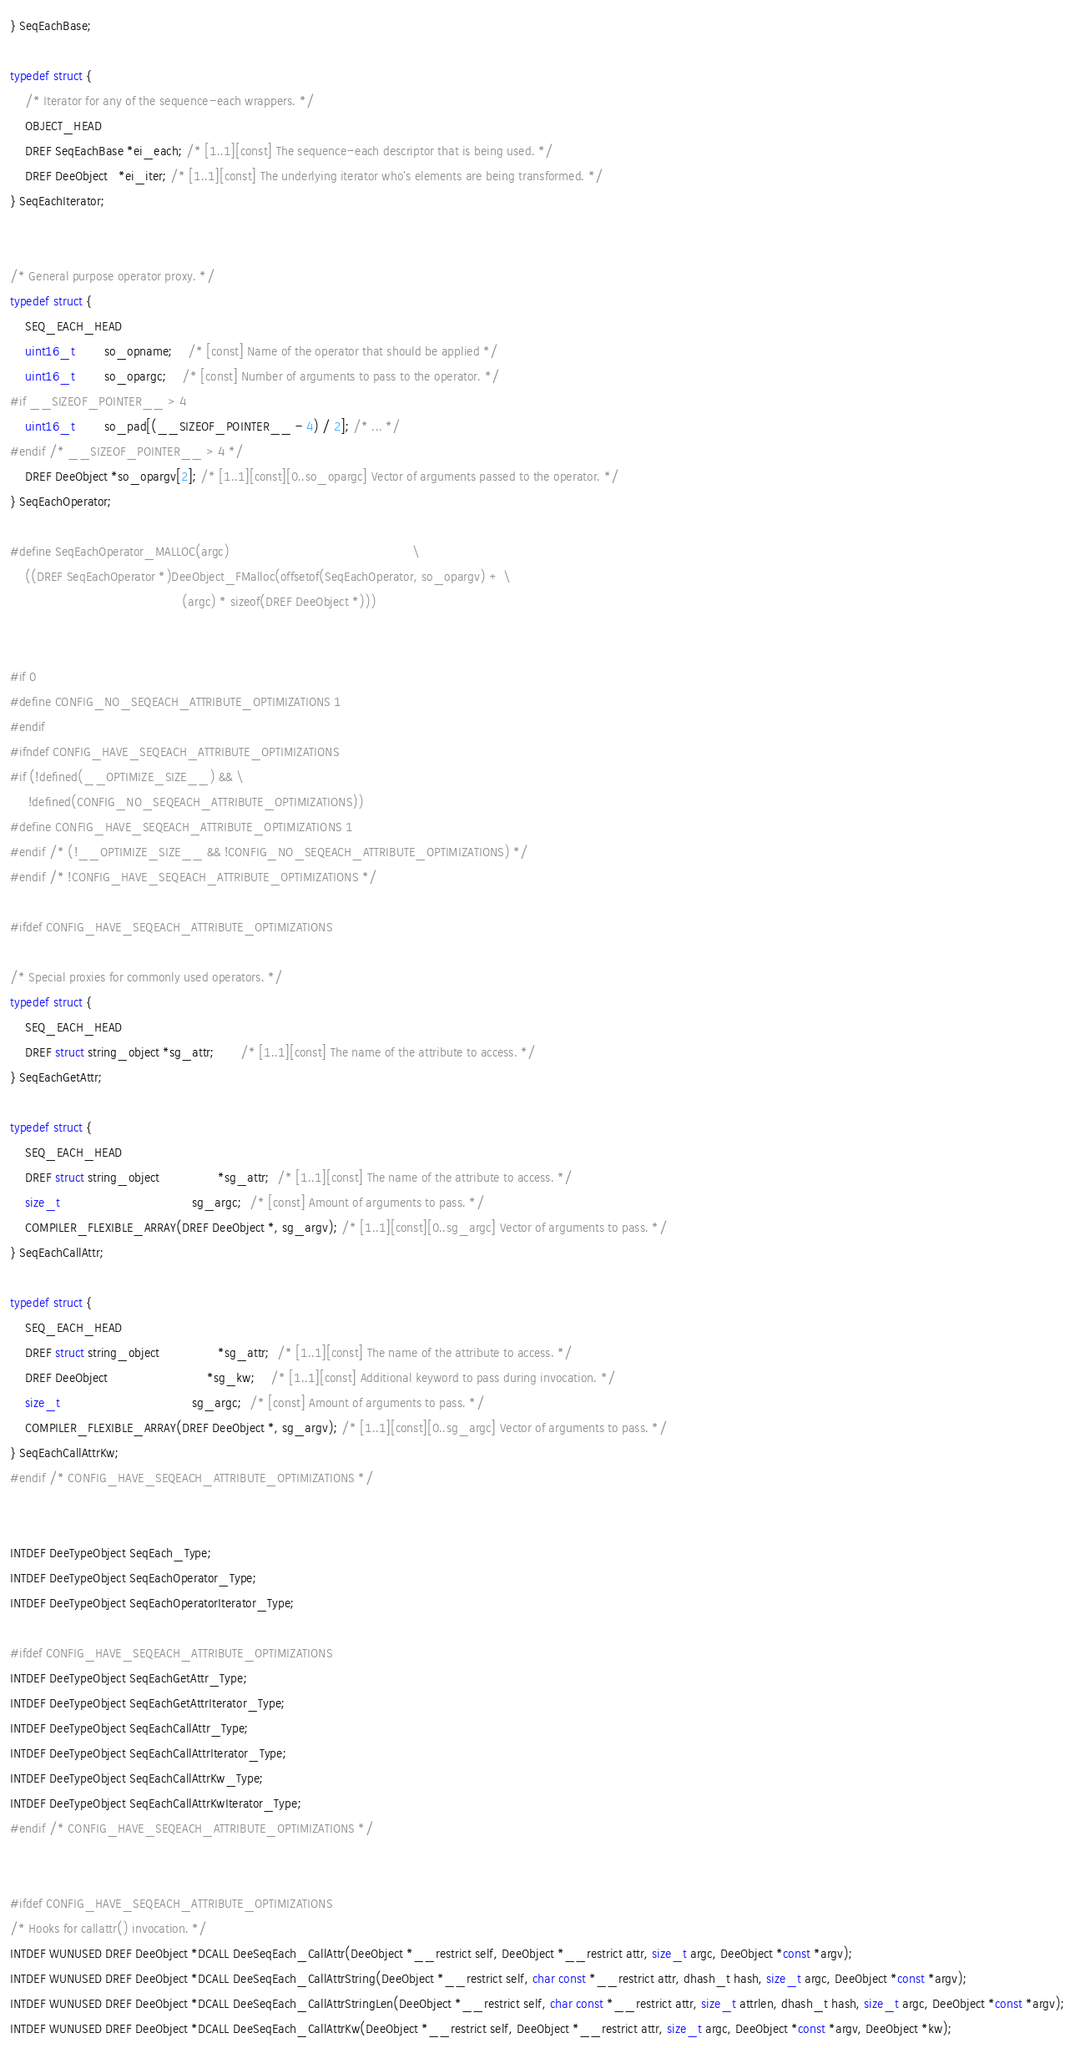<code> <loc_0><loc_0><loc_500><loc_500><_C_>} SeqEachBase;

typedef struct {
	/* Iterator for any of the sequence-each wrappers. */
	OBJECT_HEAD
	DREF SeqEachBase *ei_each; /* [1..1][const] The sequence-each descriptor that is being used. */
	DREF DeeObject   *ei_iter; /* [1..1][const] The underlying iterator who's elements are being transformed. */
} SeqEachIterator;


/* General purpose operator proxy. */
typedef struct {
	SEQ_EACH_HEAD
	uint16_t        so_opname;    /* [const] Name of the operator that should be applied */
	uint16_t        so_opargc;    /* [const] Number of arguments to pass to the operator. */
#if __SIZEOF_POINTER__ > 4
	uint16_t        so_pad[(__SIZEOF_POINTER__ - 4) / 2]; /* ... */
#endif /* __SIZEOF_POINTER__ > 4 */
	DREF DeeObject *so_opargv[2]; /* [1..1][const][0..so_opargc] Vector of arguments passed to the operator. */
} SeqEachOperator;

#define SeqEachOperator_MALLOC(argc)                                                  \
	((DREF SeqEachOperator *)DeeObject_FMalloc(offsetof(SeqEachOperator, so_opargv) + \
	                                           (argc) * sizeof(DREF DeeObject *)))


#if 0
#define CONFIG_NO_SEQEACH_ATTRIBUTE_OPTIMIZATIONS 1
#endif
#ifndef CONFIG_HAVE_SEQEACH_ATTRIBUTE_OPTIMIZATIONS
#if (!defined(__OPTIMIZE_SIZE__) && \
     !defined(CONFIG_NO_SEQEACH_ATTRIBUTE_OPTIMIZATIONS))
#define CONFIG_HAVE_SEQEACH_ATTRIBUTE_OPTIMIZATIONS 1
#endif /* (!__OPTIMIZE_SIZE__ && !CONFIG_NO_SEQEACH_ATTRIBUTE_OPTIMIZATIONS) */
#endif /* !CONFIG_HAVE_SEQEACH_ATTRIBUTE_OPTIMIZATIONS */

#ifdef CONFIG_HAVE_SEQEACH_ATTRIBUTE_OPTIMIZATIONS

/* Special proxies for commonly used operators. */
typedef struct {
	SEQ_EACH_HEAD
	DREF struct string_object *sg_attr;       /* [1..1][const] The name of the attribute to access. */
} SeqEachGetAttr;

typedef struct {
	SEQ_EACH_HEAD
	DREF struct string_object                *sg_attr;  /* [1..1][const] The name of the attribute to access. */
	size_t                                    sg_argc;  /* [const] Amount of arguments to pass. */
	COMPILER_FLEXIBLE_ARRAY(DREF DeeObject *, sg_argv); /* [1..1][const][0..sg_argc] Vector of arguments to pass. */
} SeqEachCallAttr;

typedef struct {
	SEQ_EACH_HEAD
	DREF struct string_object                *sg_attr;  /* [1..1][const] The name of the attribute to access. */
	DREF DeeObject                           *sg_kw;    /* [1..1][const] Additional keyword to pass during invocation. */
	size_t                                    sg_argc;  /* [const] Amount of arguments to pass. */
	COMPILER_FLEXIBLE_ARRAY(DREF DeeObject *, sg_argv); /* [1..1][const][0..sg_argc] Vector of arguments to pass. */
} SeqEachCallAttrKw;
#endif /* CONFIG_HAVE_SEQEACH_ATTRIBUTE_OPTIMIZATIONS */


INTDEF DeeTypeObject SeqEach_Type;
INTDEF DeeTypeObject SeqEachOperator_Type;
INTDEF DeeTypeObject SeqEachOperatorIterator_Type;

#ifdef CONFIG_HAVE_SEQEACH_ATTRIBUTE_OPTIMIZATIONS
INTDEF DeeTypeObject SeqEachGetAttr_Type;
INTDEF DeeTypeObject SeqEachGetAttrIterator_Type;
INTDEF DeeTypeObject SeqEachCallAttr_Type;
INTDEF DeeTypeObject SeqEachCallAttrIterator_Type;
INTDEF DeeTypeObject SeqEachCallAttrKw_Type;
INTDEF DeeTypeObject SeqEachCallAttrKwIterator_Type;
#endif /* CONFIG_HAVE_SEQEACH_ATTRIBUTE_OPTIMIZATIONS */


#ifdef CONFIG_HAVE_SEQEACH_ATTRIBUTE_OPTIMIZATIONS
/* Hooks for callattr() invocation. */
INTDEF WUNUSED DREF DeeObject *DCALL DeeSeqEach_CallAttr(DeeObject *__restrict self, DeeObject *__restrict attr, size_t argc, DeeObject *const *argv);
INTDEF WUNUSED DREF DeeObject *DCALL DeeSeqEach_CallAttrString(DeeObject *__restrict self, char const *__restrict attr, dhash_t hash, size_t argc, DeeObject *const *argv);
INTDEF WUNUSED DREF DeeObject *DCALL DeeSeqEach_CallAttrStringLen(DeeObject *__restrict self, char const *__restrict attr, size_t attrlen, dhash_t hash, size_t argc, DeeObject *const *argv);
INTDEF WUNUSED DREF DeeObject *DCALL DeeSeqEach_CallAttrKw(DeeObject *__restrict self, DeeObject *__restrict attr, size_t argc, DeeObject *const *argv, DeeObject *kw);</code> 